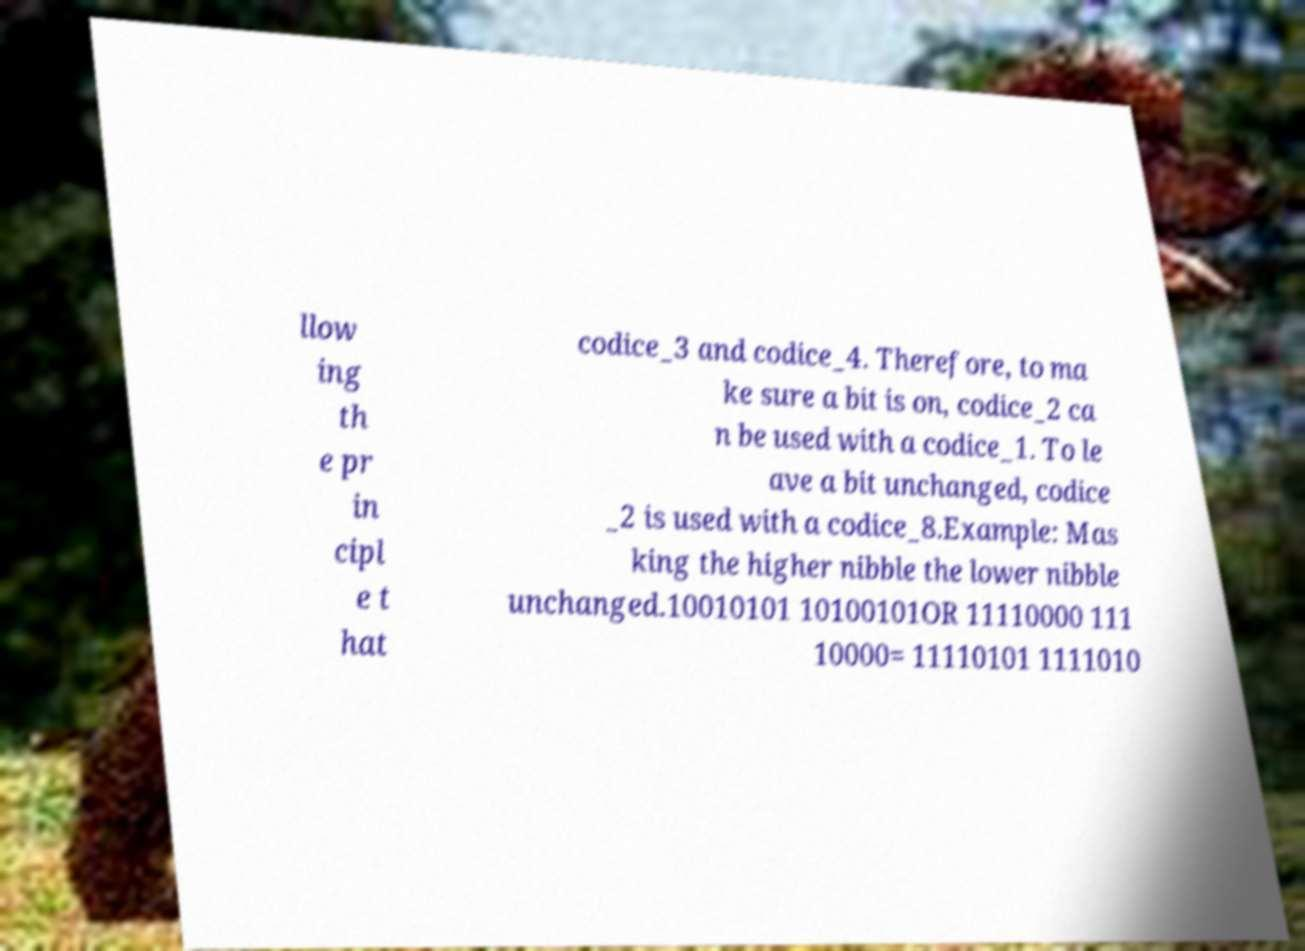Please identify and transcribe the text found in this image. llow ing th e pr in cipl e t hat codice_3 and codice_4. Therefore, to ma ke sure a bit is on, codice_2 ca n be used with a codice_1. To le ave a bit unchanged, codice _2 is used with a codice_8.Example: Mas king the higher nibble the lower nibble unchanged.10010101 10100101OR 11110000 111 10000= 11110101 1111010 